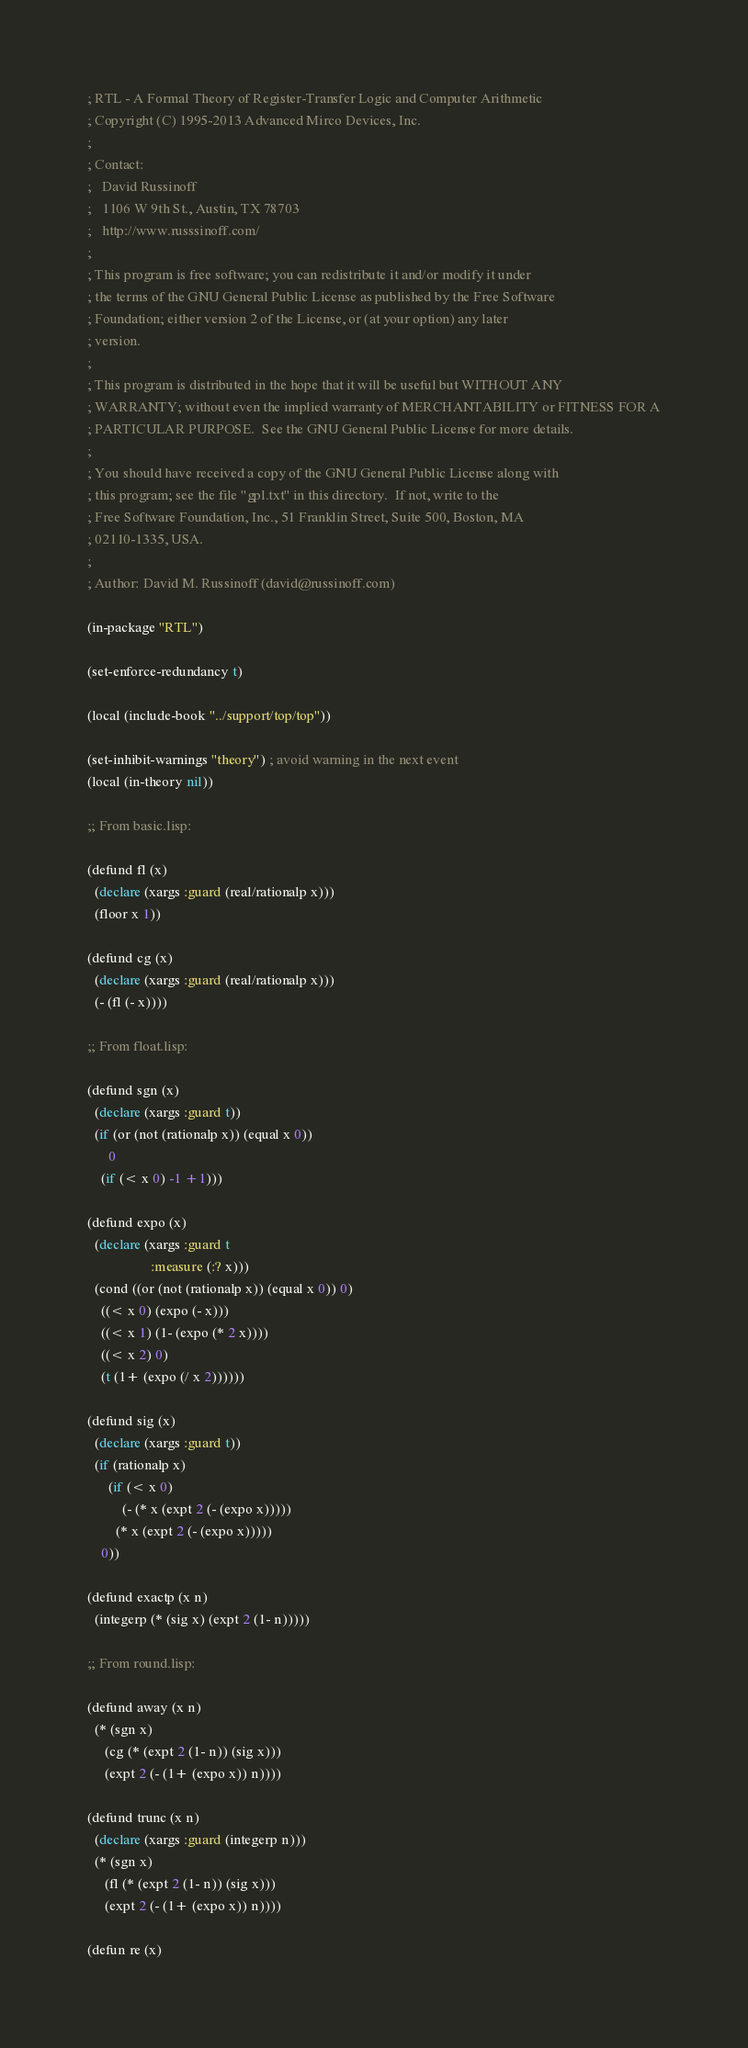Convert code to text. <code><loc_0><loc_0><loc_500><loc_500><_Lisp_>; RTL - A Formal Theory of Register-Transfer Logic and Computer Arithmetic 
; Copyright (C) 1995-2013 Advanced Mirco Devices, Inc. 
;
; Contact:
;   David Russinoff
;   1106 W 9th St., Austin, TX 78703
;   http://www.russsinoff.com/
;
; This program is free software; you can redistribute it and/or modify it under
; the terms of the GNU General Public License as published by the Free Software
; Foundation; either version 2 of the License, or (at your option) any later
; version.
;
; This program is distributed in the hope that it will be useful but WITHOUT ANY
; WARRANTY; without even the implied warranty of MERCHANTABILITY or FITNESS FOR A
; PARTICULAR PURPOSE.  See the GNU General Public License for more details.
;
; You should have received a copy of the GNU General Public License along with
; this program; see the file "gpl.txt" in this directory.  If not, write to the
; Free Software Foundation, Inc., 51 Franklin Street, Suite 500, Boston, MA
; 02110-1335, USA.
;
; Author: David M. Russinoff (david@russinoff.com)

(in-package "RTL")

(set-enforce-redundancy t)

(local (include-book "../support/top/top"))

(set-inhibit-warnings "theory") ; avoid warning in the next event
(local (in-theory nil))

;; From basic.lisp:

(defund fl (x)
  (declare (xargs :guard (real/rationalp x)))
  (floor x 1))

(defund cg (x)
  (declare (xargs :guard (real/rationalp x)))
  (- (fl (- x))))

;; From float.lisp:

(defund sgn (x) 
  (declare (xargs :guard t))
  (if (or (not (rationalp x)) (equal x 0))
      0
    (if (< x 0) -1 +1)))

(defund expo (x)
  (declare (xargs :guard t
                  :measure (:? x)))
  (cond ((or (not (rationalp x)) (equal x 0)) 0)
	((< x 0) (expo (- x)))
	((< x 1) (1- (expo (* 2 x))))
	((< x 2) 0)
	(t (1+ (expo (/ x 2))))))

(defund sig (x)
  (declare (xargs :guard t))
  (if (rationalp x)
      (if (< x 0)
          (- (* x (expt 2 (- (expo x)))))
        (* x (expt 2 (- (expo x)))))
    0))

(defund exactp (x n)
  (integerp (* (sig x) (expt 2 (1- n)))))

;; From round.lisp:

(defund away (x n)
  (* (sgn x) 
     (cg (* (expt 2 (1- n)) (sig x))) 
     (expt 2 (- (1+ (expo x)) n))))

(defund trunc (x n)
  (declare (xargs :guard (integerp n)))
  (* (sgn x) 
     (fl (* (expt 2 (1- n)) (sig x))) 
     (expt 2 (- (1+ (expo x)) n))))

(defun re (x)</code> 